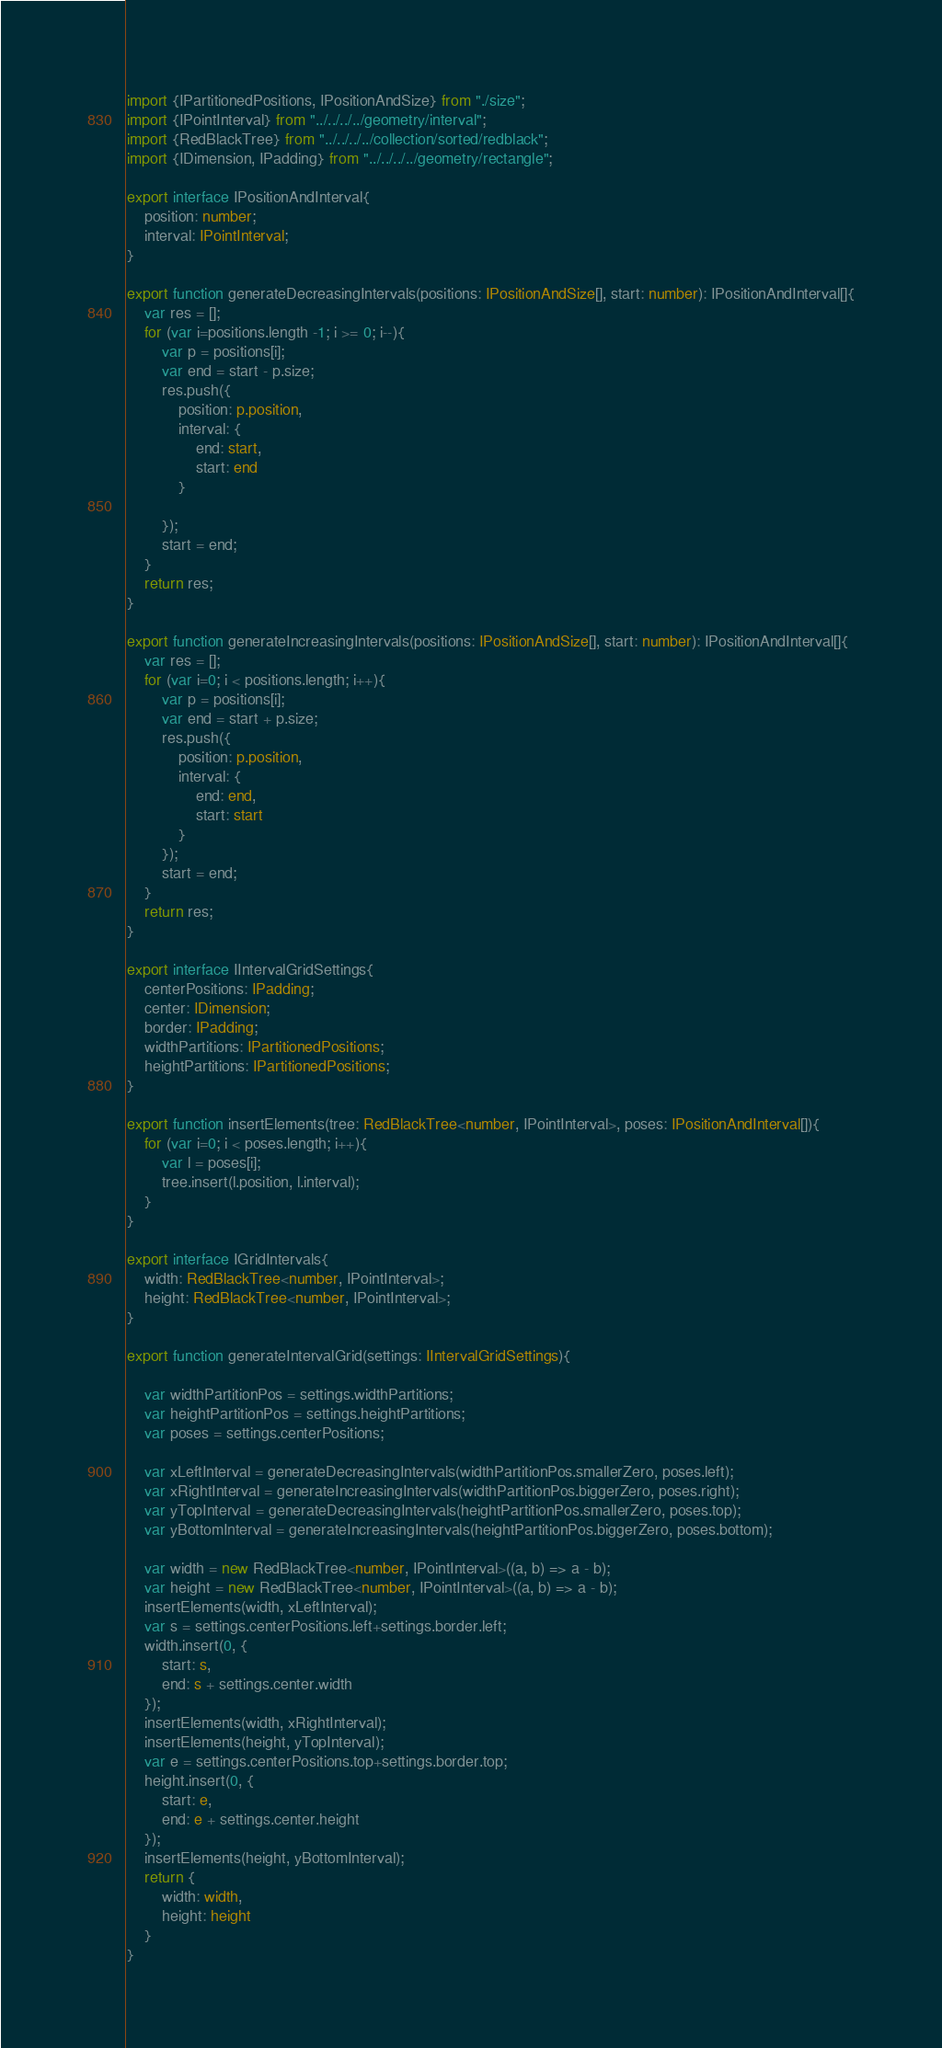Convert code to text. <code><loc_0><loc_0><loc_500><loc_500><_TypeScript_>import {IPartitionedPositions, IPositionAndSize} from "./size";
import {IPointInterval} from "../../../../geometry/interval";
import {RedBlackTree} from "../../../../collection/sorted/redblack";
import {IDimension, IPadding} from "../../../../geometry/rectangle";

export interface IPositionAndInterval{
    position: number;
    interval: IPointInterval;
}

export function generateDecreasingIntervals(positions: IPositionAndSize[], start: number): IPositionAndInterval[]{
    var res = [];
    for (var i=positions.length -1; i >= 0; i--){
        var p = positions[i];
        var end = start - p.size;
        res.push({
            position: p.position,
            interval: {
                end: start,
                start: end
            }

        });
        start = end;
    }
    return res;
}

export function generateIncreasingIntervals(positions: IPositionAndSize[], start: number): IPositionAndInterval[]{
    var res = [];
    for (var i=0; i < positions.length; i++){
        var p = positions[i];
        var end = start + p.size;
        res.push({
            position: p.position,
            interval: {
                end: end,
                start: start
            }
        });
        start = end;
    }
    return res;
}

export interface IIntervalGridSettings{
    centerPositions: IPadding;
    center: IDimension;
    border: IPadding;
    widthPartitions: IPartitionedPositions;
    heightPartitions: IPartitionedPositions;
}

export function insertElements(tree: RedBlackTree<number, IPointInterval>, poses: IPositionAndInterval[]){
    for (var i=0; i < poses.length; i++){
        var l = poses[i];
        tree.insert(l.position, l.interval);
    }
}

export interface IGridIntervals{
    width: RedBlackTree<number, IPointInterval>;
    height: RedBlackTree<number, IPointInterval>;
}

export function generateIntervalGrid(settings: IIntervalGridSettings){

    var widthPartitionPos = settings.widthPartitions;
    var heightPartitionPos = settings.heightPartitions;
    var poses = settings.centerPositions;

    var xLeftInterval = generateDecreasingIntervals(widthPartitionPos.smallerZero, poses.left);
    var xRightInterval = generateIncreasingIntervals(widthPartitionPos.biggerZero, poses.right);
    var yTopInterval = generateDecreasingIntervals(heightPartitionPos.smallerZero, poses.top);
    var yBottomInterval = generateIncreasingIntervals(heightPartitionPos.biggerZero, poses.bottom);

    var width = new RedBlackTree<number, IPointInterval>((a, b) => a - b);
    var height = new RedBlackTree<number, IPointInterval>((a, b) => a - b);
    insertElements(width, xLeftInterval);
    var s = settings.centerPositions.left+settings.border.left;
    width.insert(0, {
        start: s,
        end: s + settings.center.width
    });
    insertElements(width, xRightInterval);
    insertElements(height, yTopInterval);
    var e = settings.centerPositions.top+settings.border.top;
    height.insert(0, {
        start: e,
        end: e + settings.center.height
    });
    insertElements(height, yBottomInterval);
    return {
        width: width,
        height: height
    }
}</code> 